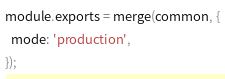Convert code to text. <code><loc_0><loc_0><loc_500><loc_500><_JavaScript_>
module.exports = merge(common, {
  mode: 'production',
});</code> 